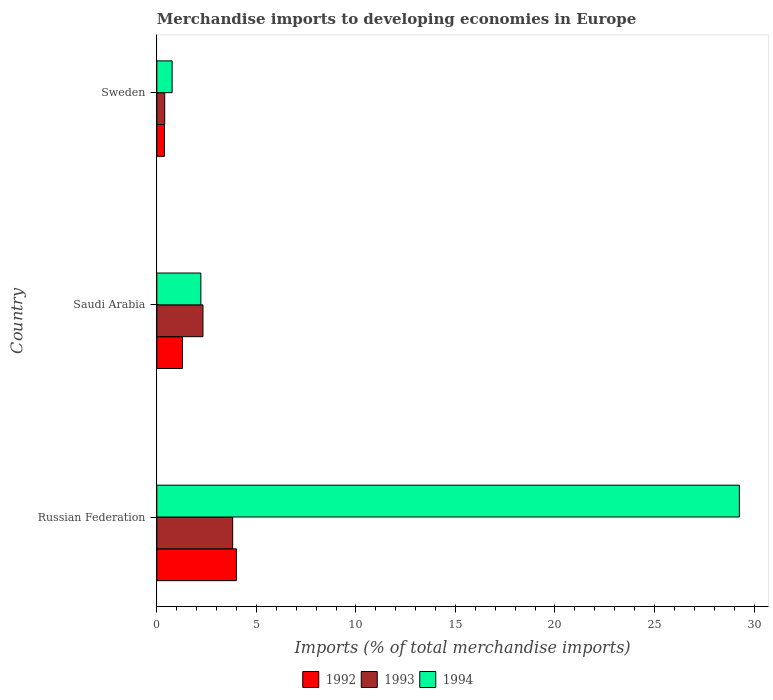Are the number of bars per tick equal to the number of legend labels?
Offer a terse response. Yes. Are the number of bars on each tick of the Y-axis equal?
Offer a very short reply. Yes. How many bars are there on the 3rd tick from the top?
Your answer should be compact. 3. How many bars are there on the 2nd tick from the bottom?
Your answer should be very brief. 3. What is the label of the 1st group of bars from the top?
Your response must be concise. Sweden. What is the percentage total merchandise imports in 1993 in Russian Federation?
Provide a succinct answer. 3.81. Across all countries, what is the maximum percentage total merchandise imports in 1992?
Make the answer very short. 4. Across all countries, what is the minimum percentage total merchandise imports in 1994?
Your response must be concise. 0.77. In which country was the percentage total merchandise imports in 1992 maximum?
Your answer should be very brief. Russian Federation. In which country was the percentage total merchandise imports in 1993 minimum?
Your response must be concise. Sweden. What is the total percentage total merchandise imports in 1993 in the graph?
Your response must be concise. 6.52. What is the difference between the percentage total merchandise imports in 1994 in Russian Federation and that in Sweden?
Provide a short and direct response. 28.5. What is the difference between the percentage total merchandise imports in 1993 in Russian Federation and the percentage total merchandise imports in 1992 in Saudi Arabia?
Keep it short and to the point. 2.52. What is the average percentage total merchandise imports in 1992 per country?
Your answer should be compact. 1.89. What is the difference between the percentage total merchandise imports in 1992 and percentage total merchandise imports in 1993 in Sweden?
Give a very brief answer. -0.01. In how many countries, is the percentage total merchandise imports in 1994 greater than 14 %?
Your answer should be very brief. 1. What is the ratio of the percentage total merchandise imports in 1994 in Saudi Arabia to that in Sweden?
Your answer should be compact. 2.88. Is the percentage total merchandise imports in 1994 in Russian Federation less than that in Saudi Arabia?
Offer a very short reply. No. What is the difference between the highest and the second highest percentage total merchandise imports in 1994?
Make the answer very short. 27.05. What is the difference between the highest and the lowest percentage total merchandise imports in 1994?
Your answer should be very brief. 28.5. What does the 2nd bar from the top in Sweden represents?
Give a very brief answer. 1993. What does the 3rd bar from the bottom in Sweden represents?
Offer a very short reply. 1994. How many bars are there?
Offer a terse response. 9. Are all the bars in the graph horizontal?
Ensure brevity in your answer.  Yes. How many countries are there in the graph?
Your response must be concise. 3. Are the values on the major ticks of X-axis written in scientific E-notation?
Give a very brief answer. No. Does the graph contain any zero values?
Offer a terse response. No. Does the graph contain grids?
Provide a short and direct response. No. How many legend labels are there?
Provide a succinct answer. 3. What is the title of the graph?
Provide a short and direct response. Merchandise imports to developing economies in Europe. Does "1987" appear as one of the legend labels in the graph?
Ensure brevity in your answer.  No. What is the label or title of the X-axis?
Ensure brevity in your answer.  Imports (% of total merchandise imports). What is the Imports (% of total merchandise imports) of 1992 in Russian Federation?
Keep it short and to the point. 4. What is the Imports (% of total merchandise imports) of 1993 in Russian Federation?
Your answer should be very brief. 3.81. What is the Imports (% of total merchandise imports) in 1994 in Russian Federation?
Your answer should be compact. 29.26. What is the Imports (% of total merchandise imports) of 1992 in Saudi Arabia?
Provide a short and direct response. 1.29. What is the Imports (% of total merchandise imports) in 1993 in Saudi Arabia?
Your answer should be very brief. 2.32. What is the Imports (% of total merchandise imports) of 1994 in Saudi Arabia?
Give a very brief answer. 2.21. What is the Imports (% of total merchandise imports) in 1992 in Sweden?
Offer a terse response. 0.38. What is the Imports (% of total merchandise imports) in 1993 in Sweden?
Make the answer very short. 0.39. What is the Imports (% of total merchandise imports) in 1994 in Sweden?
Your response must be concise. 0.77. Across all countries, what is the maximum Imports (% of total merchandise imports) in 1992?
Your answer should be compact. 4. Across all countries, what is the maximum Imports (% of total merchandise imports) in 1993?
Provide a succinct answer. 3.81. Across all countries, what is the maximum Imports (% of total merchandise imports) of 1994?
Keep it short and to the point. 29.26. Across all countries, what is the minimum Imports (% of total merchandise imports) of 1992?
Ensure brevity in your answer.  0.38. Across all countries, what is the minimum Imports (% of total merchandise imports) of 1993?
Offer a very short reply. 0.39. Across all countries, what is the minimum Imports (% of total merchandise imports) in 1994?
Ensure brevity in your answer.  0.77. What is the total Imports (% of total merchandise imports) of 1992 in the graph?
Give a very brief answer. 5.66. What is the total Imports (% of total merchandise imports) in 1993 in the graph?
Offer a terse response. 6.52. What is the total Imports (% of total merchandise imports) of 1994 in the graph?
Offer a terse response. 32.24. What is the difference between the Imports (% of total merchandise imports) in 1992 in Russian Federation and that in Saudi Arabia?
Provide a short and direct response. 2.71. What is the difference between the Imports (% of total merchandise imports) in 1993 in Russian Federation and that in Saudi Arabia?
Give a very brief answer. 1.49. What is the difference between the Imports (% of total merchandise imports) in 1994 in Russian Federation and that in Saudi Arabia?
Provide a short and direct response. 27.05. What is the difference between the Imports (% of total merchandise imports) of 1992 in Russian Federation and that in Sweden?
Offer a very short reply. 3.61. What is the difference between the Imports (% of total merchandise imports) in 1993 in Russian Federation and that in Sweden?
Ensure brevity in your answer.  3.41. What is the difference between the Imports (% of total merchandise imports) in 1994 in Russian Federation and that in Sweden?
Make the answer very short. 28.5. What is the difference between the Imports (% of total merchandise imports) of 1992 in Saudi Arabia and that in Sweden?
Provide a succinct answer. 0.9. What is the difference between the Imports (% of total merchandise imports) of 1993 in Saudi Arabia and that in Sweden?
Your answer should be compact. 1.92. What is the difference between the Imports (% of total merchandise imports) of 1994 in Saudi Arabia and that in Sweden?
Your response must be concise. 1.44. What is the difference between the Imports (% of total merchandise imports) of 1992 in Russian Federation and the Imports (% of total merchandise imports) of 1993 in Saudi Arabia?
Provide a short and direct response. 1.68. What is the difference between the Imports (% of total merchandise imports) in 1992 in Russian Federation and the Imports (% of total merchandise imports) in 1994 in Saudi Arabia?
Your answer should be compact. 1.79. What is the difference between the Imports (% of total merchandise imports) of 1993 in Russian Federation and the Imports (% of total merchandise imports) of 1994 in Saudi Arabia?
Ensure brevity in your answer.  1.6. What is the difference between the Imports (% of total merchandise imports) in 1992 in Russian Federation and the Imports (% of total merchandise imports) in 1993 in Sweden?
Ensure brevity in your answer.  3.6. What is the difference between the Imports (% of total merchandise imports) of 1992 in Russian Federation and the Imports (% of total merchandise imports) of 1994 in Sweden?
Keep it short and to the point. 3.23. What is the difference between the Imports (% of total merchandise imports) of 1993 in Russian Federation and the Imports (% of total merchandise imports) of 1994 in Sweden?
Provide a succinct answer. 3.04. What is the difference between the Imports (% of total merchandise imports) in 1992 in Saudi Arabia and the Imports (% of total merchandise imports) in 1993 in Sweden?
Keep it short and to the point. 0.89. What is the difference between the Imports (% of total merchandise imports) of 1992 in Saudi Arabia and the Imports (% of total merchandise imports) of 1994 in Sweden?
Your response must be concise. 0.52. What is the difference between the Imports (% of total merchandise imports) of 1993 in Saudi Arabia and the Imports (% of total merchandise imports) of 1994 in Sweden?
Offer a terse response. 1.55. What is the average Imports (% of total merchandise imports) in 1992 per country?
Make the answer very short. 1.89. What is the average Imports (% of total merchandise imports) in 1993 per country?
Your answer should be very brief. 2.17. What is the average Imports (% of total merchandise imports) of 1994 per country?
Ensure brevity in your answer.  10.75. What is the difference between the Imports (% of total merchandise imports) in 1992 and Imports (% of total merchandise imports) in 1993 in Russian Federation?
Your answer should be very brief. 0.19. What is the difference between the Imports (% of total merchandise imports) of 1992 and Imports (% of total merchandise imports) of 1994 in Russian Federation?
Your answer should be compact. -25.27. What is the difference between the Imports (% of total merchandise imports) of 1993 and Imports (% of total merchandise imports) of 1994 in Russian Federation?
Offer a very short reply. -25.46. What is the difference between the Imports (% of total merchandise imports) in 1992 and Imports (% of total merchandise imports) in 1993 in Saudi Arabia?
Provide a succinct answer. -1.03. What is the difference between the Imports (% of total merchandise imports) in 1992 and Imports (% of total merchandise imports) in 1994 in Saudi Arabia?
Ensure brevity in your answer.  -0.92. What is the difference between the Imports (% of total merchandise imports) of 1993 and Imports (% of total merchandise imports) of 1994 in Saudi Arabia?
Make the answer very short. 0.11. What is the difference between the Imports (% of total merchandise imports) in 1992 and Imports (% of total merchandise imports) in 1993 in Sweden?
Your answer should be compact. -0.01. What is the difference between the Imports (% of total merchandise imports) of 1992 and Imports (% of total merchandise imports) of 1994 in Sweden?
Provide a succinct answer. -0.39. What is the difference between the Imports (% of total merchandise imports) in 1993 and Imports (% of total merchandise imports) in 1994 in Sweden?
Provide a succinct answer. -0.37. What is the ratio of the Imports (% of total merchandise imports) in 1992 in Russian Federation to that in Saudi Arabia?
Give a very brief answer. 3.11. What is the ratio of the Imports (% of total merchandise imports) of 1993 in Russian Federation to that in Saudi Arabia?
Give a very brief answer. 1.64. What is the ratio of the Imports (% of total merchandise imports) in 1994 in Russian Federation to that in Saudi Arabia?
Offer a very short reply. 13.24. What is the ratio of the Imports (% of total merchandise imports) in 1992 in Russian Federation to that in Sweden?
Keep it short and to the point. 10.44. What is the ratio of the Imports (% of total merchandise imports) of 1993 in Russian Federation to that in Sweden?
Offer a terse response. 9.66. What is the ratio of the Imports (% of total merchandise imports) in 1994 in Russian Federation to that in Sweden?
Offer a very short reply. 38.12. What is the ratio of the Imports (% of total merchandise imports) of 1992 in Saudi Arabia to that in Sweden?
Give a very brief answer. 3.36. What is the ratio of the Imports (% of total merchandise imports) of 1993 in Saudi Arabia to that in Sweden?
Your answer should be compact. 5.87. What is the ratio of the Imports (% of total merchandise imports) of 1994 in Saudi Arabia to that in Sweden?
Offer a terse response. 2.88. What is the difference between the highest and the second highest Imports (% of total merchandise imports) in 1992?
Provide a succinct answer. 2.71. What is the difference between the highest and the second highest Imports (% of total merchandise imports) in 1993?
Your answer should be compact. 1.49. What is the difference between the highest and the second highest Imports (% of total merchandise imports) of 1994?
Your response must be concise. 27.05. What is the difference between the highest and the lowest Imports (% of total merchandise imports) of 1992?
Your answer should be compact. 3.61. What is the difference between the highest and the lowest Imports (% of total merchandise imports) of 1993?
Offer a terse response. 3.41. What is the difference between the highest and the lowest Imports (% of total merchandise imports) of 1994?
Give a very brief answer. 28.5. 